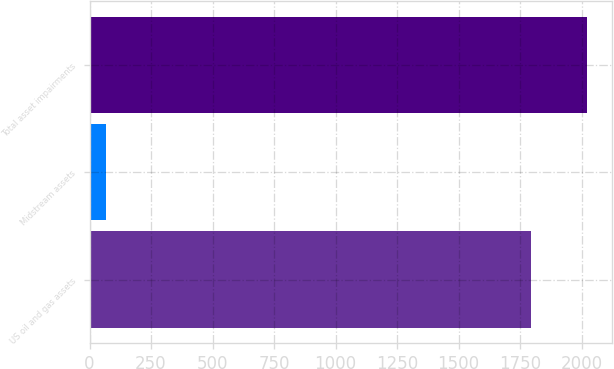Convert chart to OTSL. <chart><loc_0><loc_0><loc_500><loc_500><bar_chart><fcel>US oil and gas assets<fcel>Midstream assets<fcel>Total asset impairments<nl><fcel>1793<fcel>68<fcel>2024<nl></chart> 